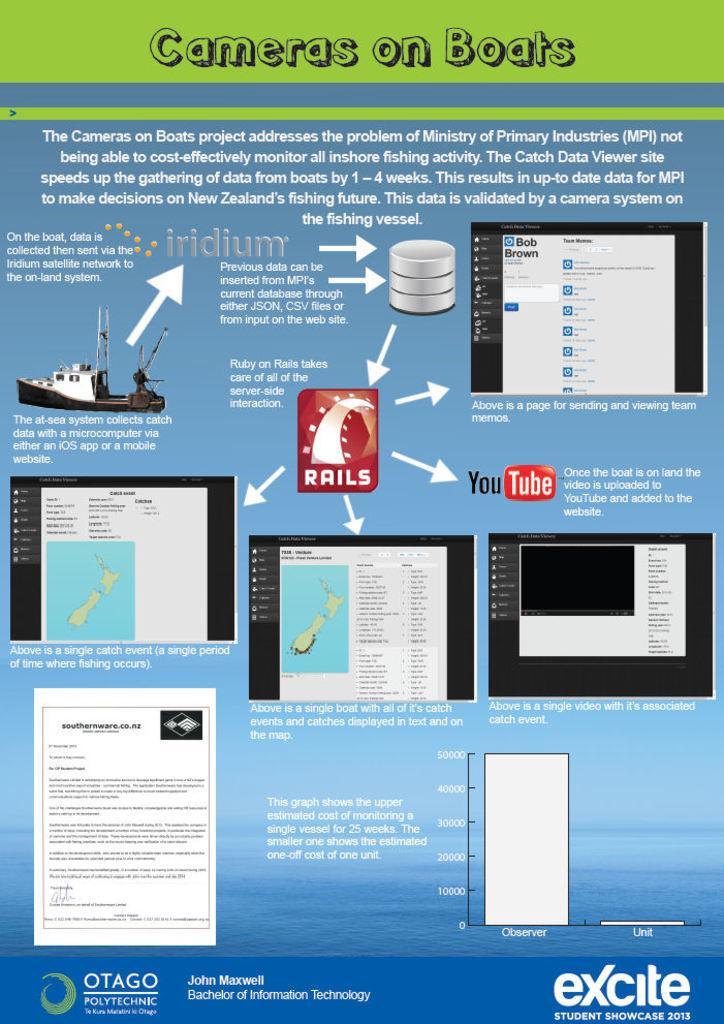Describe this image in one or two sentences. In this image we can see one poster with text and images. 